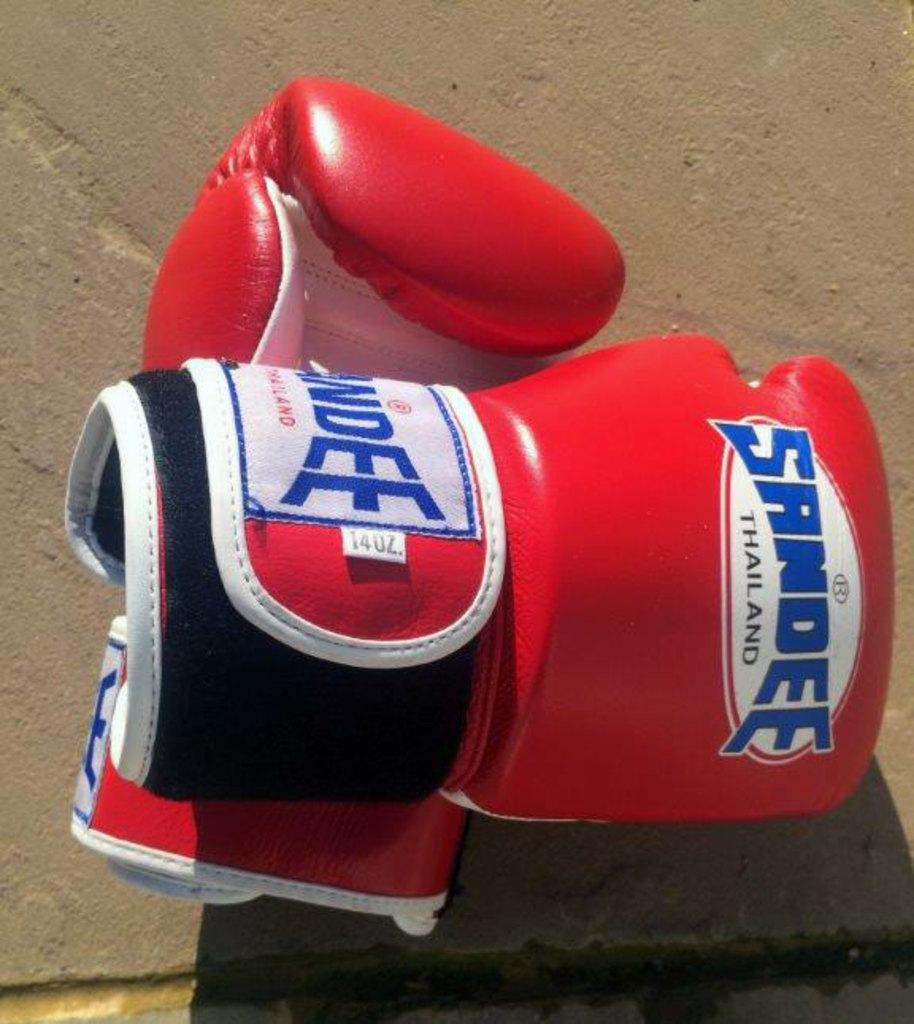<image>
Create a compact narrative representing the image presented. two red boxing gloves from sandee brand they look new 